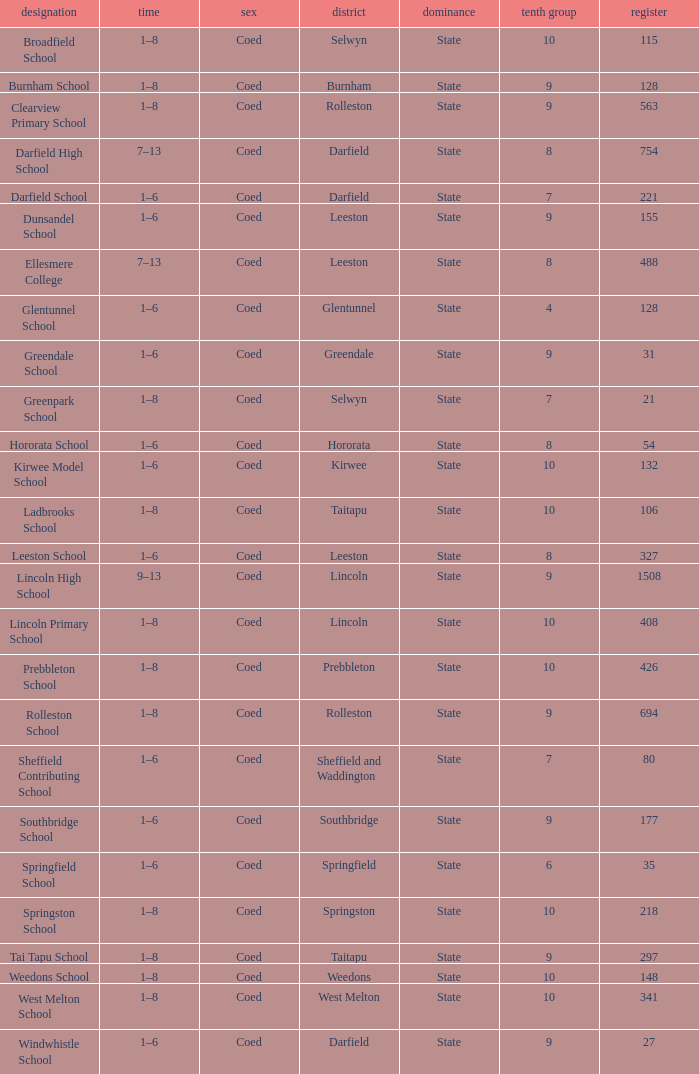Which area has a Decile of 9, and a Roll of 31? Greendale. 